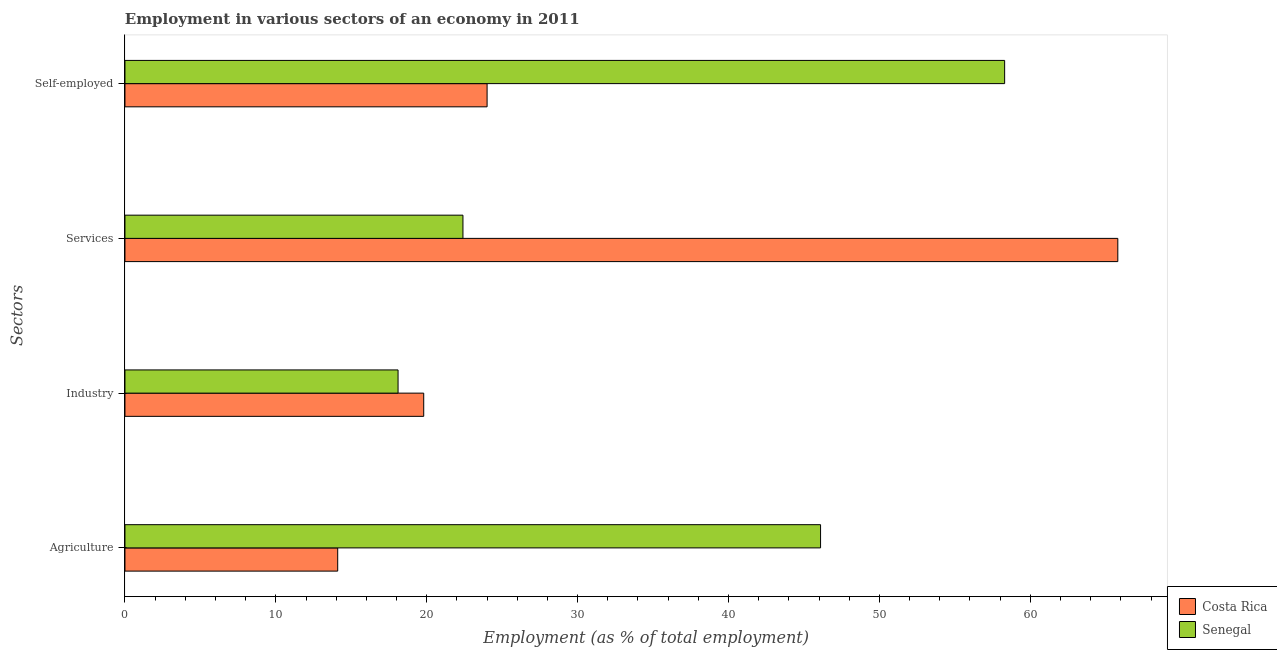How many different coloured bars are there?
Give a very brief answer. 2. Are the number of bars on each tick of the Y-axis equal?
Provide a succinct answer. Yes. How many bars are there on the 4th tick from the bottom?
Give a very brief answer. 2. What is the label of the 3rd group of bars from the top?
Give a very brief answer. Industry. What is the percentage of workers in industry in Senegal?
Offer a terse response. 18.1. Across all countries, what is the maximum percentage of self employed workers?
Keep it short and to the point. 58.3. Across all countries, what is the minimum percentage of workers in services?
Your answer should be compact. 22.4. In which country was the percentage of self employed workers maximum?
Ensure brevity in your answer.  Senegal. In which country was the percentage of workers in services minimum?
Ensure brevity in your answer.  Senegal. What is the total percentage of workers in agriculture in the graph?
Offer a very short reply. 60.2. What is the difference between the percentage of workers in industry in Costa Rica and that in Senegal?
Provide a short and direct response. 1.7. What is the difference between the percentage of workers in services in Senegal and the percentage of self employed workers in Costa Rica?
Keep it short and to the point. -1.6. What is the average percentage of workers in agriculture per country?
Your answer should be compact. 30.1. What is the difference between the percentage of self employed workers and percentage of workers in industry in Senegal?
Make the answer very short. 40.2. In how many countries, is the percentage of workers in services greater than 40 %?
Your response must be concise. 1. What is the ratio of the percentage of workers in agriculture in Senegal to that in Costa Rica?
Offer a very short reply. 3.27. Is the difference between the percentage of workers in services in Costa Rica and Senegal greater than the difference between the percentage of workers in agriculture in Costa Rica and Senegal?
Offer a very short reply. Yes. What is the difference between the highest and the second highest percentage of workers in industry?
Provide a short and direct response. 1.7. What is the difference between the highest and the lowest percentage of workers in industry?
Your answer should be very brief. 1.7. In how many countries, is the percentage of workers in agriculture greater than the average percentage of workers in agriculture taken over all countries?
Ensure brevity in your answer.  1. Is the sum of the percentage of self employed workers in Costa Rica and Senegal greater than the maximum percentage of workers in agriculture across all countries?
Offer a terse response. Yes. Is it the case that in every country, the sum of the percentage of workers in industry and percentage of self employed workers is greater than the sum of percentage of workers in services and percentage of workers in agriculture?
Ensure brevity in your answer.  No. What does the 2nd bar from the top in Agriculture represents?
Give a very brief answer. Costa Rica. What does the 2nd bar from the bottom in Self-employed represents?
Offer a terse response. Senegal. Is it the case that in every country, the sum of the percentage of workers in agriculture and percentage of workers in industry is greater than the percentage of workers in services?
Your answer should be compact. No. Are all the bars in the graph horizontal?
Your answer should be compact. Yes. How many countries are there in the graph?
Keep it short and to the point. 2. Does the graph contain any zero values?
Your answer should be very brief. No. Does the graph contain grids?
Ensure brevity in your answer.  No. Where does the legend appear in the graph?
Your response must be concise. Bottom right. What is the title of the graph?
Offer a terse response. Employment in various sectors of an economy in 2011. Does "Virgin Islands" appear as one of the legend labels in the graph?
Give a very brief answer. No. What is the label or title of the X-axis?
Ensure brevity in your answer.  Employment (as % of total employment). What is the label or title of the Y-axis?
Offer a very short reply. Sectors. What is the Employment (as % of total employment) in Costa Rica in Agriculture?
Make the answer very short. 14.1. What is the Employment (as % of total employment) in Senegal in Agriculture?
Provide a short and direct response. 46.1. What is the Employment (as % of total employment) of Costa Rica in Industry?
Provide a succinct answer. 19.8. What is the Employment (as % of total employment) of Senegal in Industry?
Provide a succinct answer. 18.1. What is the Employment (as % of total employment) of Costa Rica in Services?
Your answer should be very brief. 65.8. What is the Employment (as % of total employment) in Senegal in Services?
Your answer should be compact. 22.4. What is the Employment (as % of total employment) of Senegal in Self-employed?
Provide a short and direct response. 58.3. Across all Sectors, what is the maximum Employment (as % of total employment) of Costa Rica?
Keep it short and to the point. 65.8. Across all Sectors, what is the maximum Employment (as % of total employment) of Senegal?
Your answer should be compact. 58.3. Across all Sectors, what is the minimum Employment (as % of total employment) in Costa Rica?
Your response must be concise. 14.1. Across all Sectors, what is the minimum Employment (as % of total employment) of Senegal?
Your response must be concise. 18.1. What is the total Employment (as % of total employment) of Costa Rica in the graph?
Offer a very short reply. 123.7. What is the total Employment (as % of total employment) of Senegal in the graph?
Provide a succinct answer. 144.9. What is the difference between the Employment (as % of total employment) in Costa Rica in Agriculture and that in Industry?
Provide a short and direct response. -5.7. What is the difference between the Employment (as % of total employment) of Costa Rica in Agriculture and that in Services?
Provide a succinct answer. -51.7. What is the difference between the Employment (as % of total employment) in Senegal in Agriculture and that in Services?
Ensure brevity in your answer.  23.7. What is the difference between the Employment (as % of total employment) of Costa Rica in Agriculture and that in Self-employed?
Make the answer very short. -9.9. What is the difference between the Employment (as % of total employment) in Costa Rica in Industry and that in Services?
Your answer should be compact. -46. What is the difference between the Employment (as % of total employment) of Costa Rica in Industry and that in Self-employed?
Your answer should be very brief. -4.2. What is the difference between the Employment (as % of total employment) of Senegal in Industry and that in Self-employed?
Offer a very short reply. -40.2. What is the difference between the Employment (as % of total employment) of Costa Rica in Services and that in Self-employed?
Your answer should be compact. 41.8. What is the difference between the Employment (as % of total employment) in Senegal in Services and that in Self-employed?
Make the answer very short. -35.9. What is the difference between the Employment (as % of total employment) of Costa Rica in Agriculture and the Employment (as % of total employment) of Senegal in Industry?
Keep it short and to the point. -4. What is the difference between the Employment (as % of total employment) in Costa Rica in Agriculture and the Employment (as % of total employment) in Senegal in Services?
Make the answer very short. -8.3. What is the difference between the Employment (as % of total employment) of Costa Rica in Agriculture and the Employment (as % of total employment) of Senegal in Self-employed?
Make the answer very short. -44.2. What is the difference between the Employment (as % of total employment) in Costa Rica in Industry and the Employment (as % of total employment) in Senegal in Self-employed?
Your answer should be very brief. -38.5. What is the difference between the Employment (as % of total employment) in Costa Rica in Services and the Employment (as % of total employment) in Senegal in Self-employed?
Offer a terse response. 7.5. What is the average Employment (as % of total employment) in Costa Rica per Sectors?
Provide a short and direct response. 30.93. What is the average Employment (as % of total employment) of Senegal per Sectors?
Your answer should be very brief. 36.23. What is the difference between the Employment (as % of total employment) in Costa Rica and Employment (as % of total employment) in Senegal in Agriculture?
Ensure brevity in your answer.  -32. What is the difference between the Employment (as % of total employment) of Costa Rica and Employment (as % of total employment) of Senegal in Services?
Provide a succinct answer. 43.4. What is the difference between the Employment (as % of total employment) of Costa Rica and Employment (as % of total employment) of Senegal in Self-employed?
Make the answer very short. -34.3. What is the ratio of the Employment (as % of total employment) in Costa Rica in Agriculture to that in Industry?
Your answer should be compact. 0.71. What is the ratio of the Employment (as % of total employment) of Senegal in Agriculture to that in Industry?
Give a very brief answer. 2.55. What is the ratio of the Employment (as % of total employment) in Costa Rica in Agriculture to that in Services?
Your answer should be compact. 0.21. What is the ratio of the Employment (as % of total employment) of Senegal in Agriculture to that in Services?
Give a very brief answer. 2.06. What is the ratio of the Employment (as % of total employment) of Costa Rica in Agriculture to that in Self-employed?
Your response must be concise. 0.59. What is the ratio of the Employment (as % of total employment) of Senegal in Agriculture to that in Self-employed?
Offer a very short reply. 0.79. What is the ratio of the Employment (as % of total employment) of Costa Rica in Industry to that in Services?
Your response must be concise. 0.3. What is the ratio of the Employment (as % of total employment) in Senegal in Industry to that in Services?
Make the answer very short. 0.81. What is the ratio of the Employment (as % of total employment) in Costa Rica in Industry to that in Self-employed?
Your answer should be very brief. 0.82. What is the ratio of the Employment (as % of total employment) in Senegal in Industry to that in Self-employed?
Your answer should be very brief. 0.31. What is the ratio of the Employment (as % of total employment) in Costa Rica in Services to that in Self-employed?
Make the answer very short. 2.74. What is the ratio of the Employment (as % of total employment) in Senegal in Services to that in Self-employed?
Ensure brevity in your answer.  0.38. What is the difference between the highest and the second highest Employment (as % of total employment) in Costa Rica?
Provide a short and direct response. 41.8. What is the difference between the highest and the second highest Employment (as % of total employment) of Senegal?
Provide a short and direct response. 12.2. What is the difference between the highest and the lowest Employment (as % of total employment) of Costa Rica?
Provide a short and direct response. 51.7. What is the difference between the highest and the lowest Employment (as % of total employment) of Senegal?
Provide a succinct answer. 40.2. 